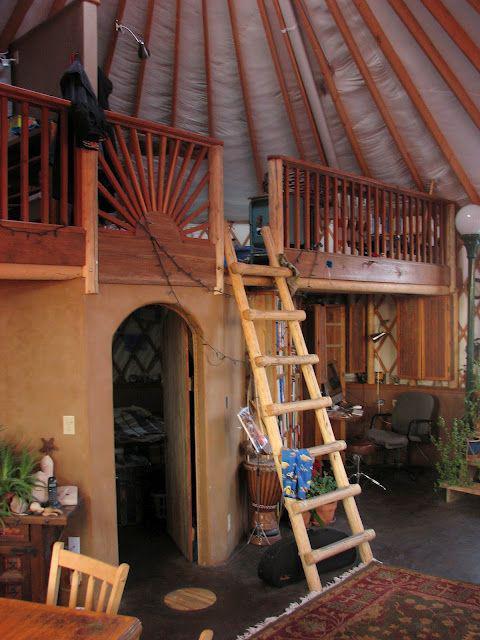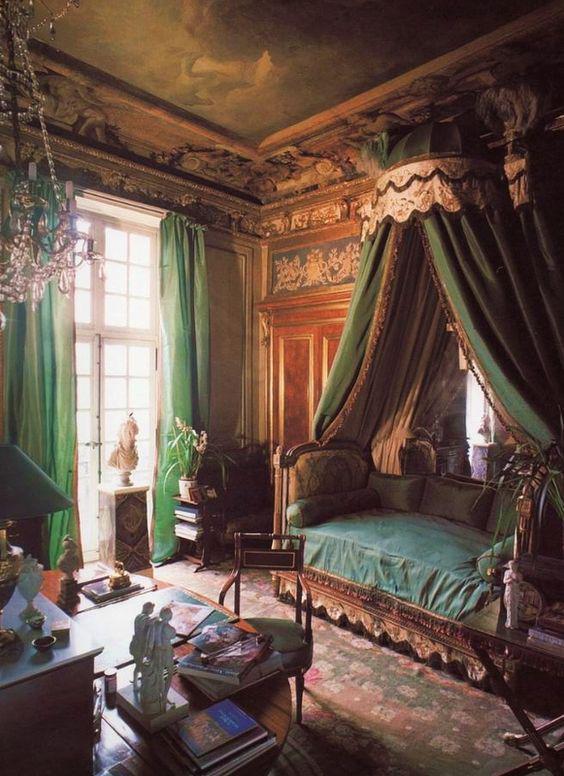The first image is the image on the left, the second image is the image on the right. Given the left and right images, does the statement "One of the images shows a second floor balcony area with a wooden railing." hold true? Answer yes or no. Yes. 